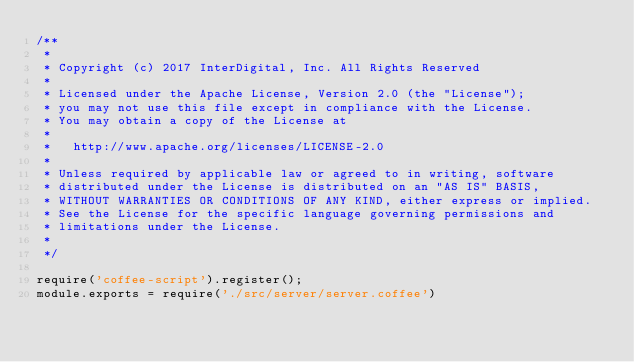<code> <loc_0><loc_0><loc_500><loc_500><_JavaScript_>/**
 *
 * Copyright (c) 2017 InterDigital, Inc. All Rights Reserved
 *
 * Licensed under the Apache License, Version 2.0 (the "License");
 * you may not use this file except in compliance with the License.
 * You may obtain a copy of the License at
 *
 *   http://www.apache.org/licenses/LICENSE-2.0
 *
 * Unless required by applicable law or agreed to in writing, software
 * distributed under the License is distributed on an "AS IS" BASIS,
 * WITHOUT WARRANTIES OR CONDITIONS OF ANY KIND, either express or implied.
 * See the License for the specific language governing permissions and
 * limitations under the License.
 *
 */

require('coffee-script').register();
module.exports = require('./src/server/server.coffee')
</code> 